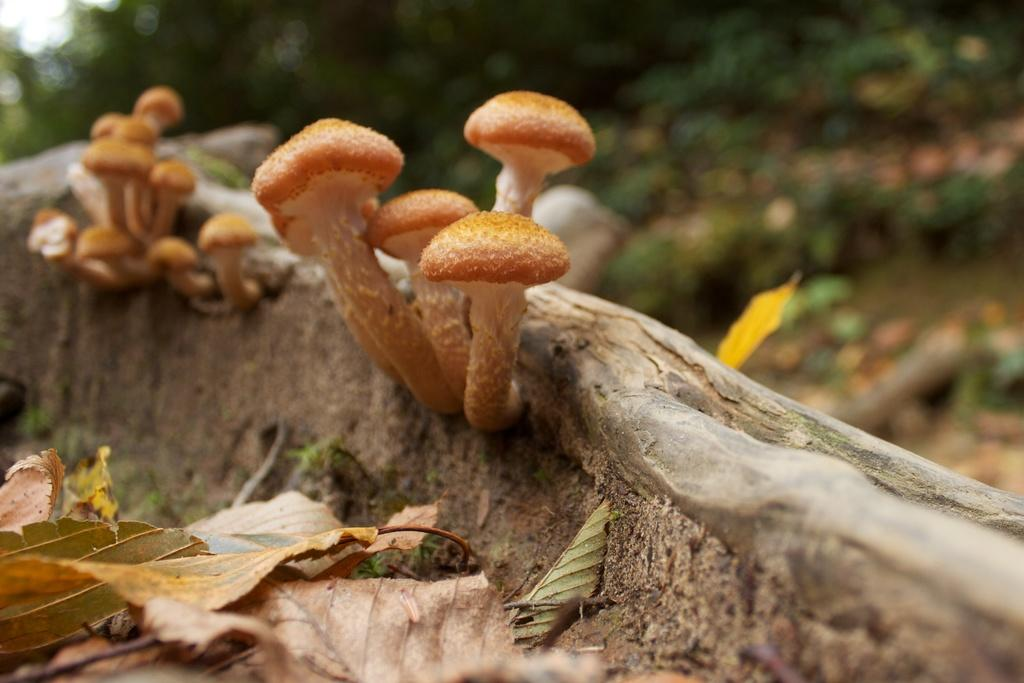What can be seen in the front of the image? There are leaves and mushrooms in the front of the image. What is visible in the background of the image? There are trees in the background of the image. How is the background of the image depicted? The background of the image is slightly blurred. Who is the guide leading through the plants in the image? There is no guide present in the image, and no one is leading anyone through the plants. 